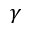Convert formula to latex. <formula><loc_0><loc_0><loc_500><loc_500>\gamma</formula> 